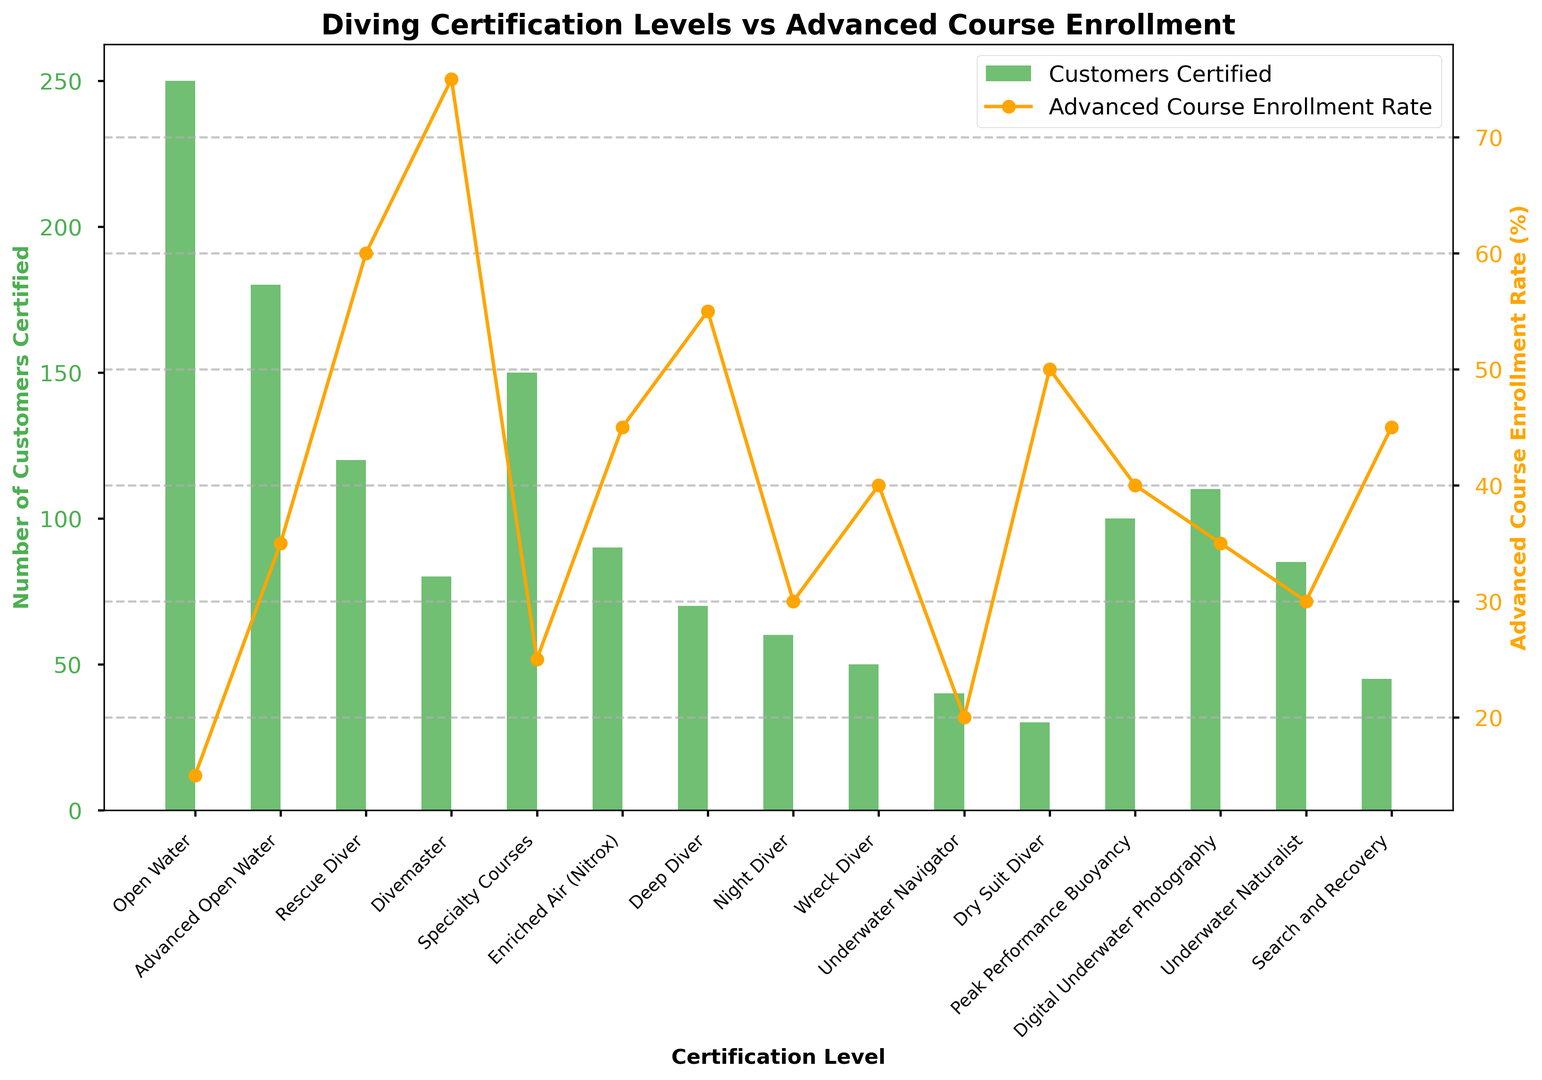Which certification level has the highest number of customers certified? To find the highest number of customers certified, look at the bar heights. The highest bar represents the "Open Water" certification level.
Answer: Open Water Which certification level has the highest advanced course enrollment rate? Look at the highest point on the line chart representing advanced course enrollment rates. The highest point corresponds to the "Divemaster" level.
Answer: Divemaster What is the difference in the number of customers certified between "Advanced Open Water" and "Rescue Diver"? Find the bar heights for both "Advanced Open Water" and "Rescue Diver". The "Advanced Open Water" has 180 customers, and "Rescue Diver" has 120 customers. The difference is 180 - 120.
Answer: 60 Which certification has a higher advanced course enrollment rate: "Specialty Courses" or "Digital Underwater Photography"? Compare the points on the line chart for both certifications. "Digital Underwater Photography" has a 35% enrollment rate, while "Specialty Courses" has a 25% enrollment rate.
Answer: Digital Underwater Photography What is the enrollment rate for "Enriched Air (Nitrox)"? Locate the "Enriched Air (Nitrox)" certification on the x-axis and follow the line directly upwards to the corresponding point, which shows the enrollment rate.
Answer: 45% Which certification has a lower advanced course enrollment rate: "Peak Performance Buoyancy" or "Rescue Diver"? Compare the points on the line chart for both certifications. "Peak Performance Buoyancy" has a 40% enrollment rate, while "Rescue Diver" has a 60% enrollment rate.
Answer: Peak Performance Buoyancy Which certification level shows the largest discrepancy between its number of customers certified and its advanced course enrollment rate? This requires examining both measures for each certification. "Divemaster" has a large discrepancy with 80 customers certified and a 75% enrollment rate, indicating major interest in further certification relative to its customer base.
Answer: Divemaster What is the average advanced course enrollment rate for “Underwater Navigator” and “Dry Suit Diver”? Find the enrollment rates for both certifications: "Underwater Navigator" (20%) and "Dry Suit Diver" (50%). Calculate the average: (20 + 50) / 2.
Answer: 35% How many more customers are certified in "Open Water" than in "Night Diver"? Look at the bar heights. "Open Water" has 250 customers certified, "Night Diver" has 60. The difference is 250 - 60.
Answer: 190 